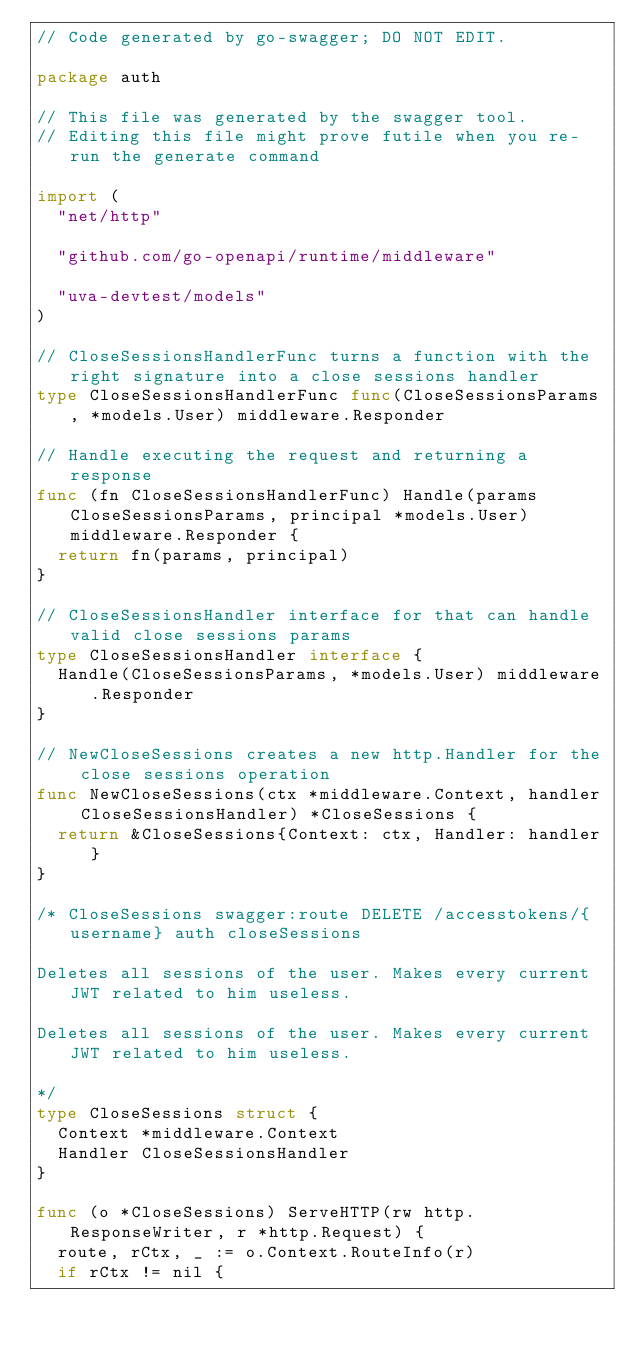Convert code to text. <code><loc_0><loc_0><loc_500><loc_500><_Go_>// Code generated by go-swagger; DO NOT EDIT.

package auth

// This file was generated by the swagger tool.
// Editing this file might prove futile when you re-run the generate command

import (
	"net/http"

	"github.com/go-openapi/runtime/middleware"

	"uva-devtest/models"
)

// CloseSessionsHandlerFunc turns a function with the right signature into a close sessions handler
type CloseSessionsHandlerFunc func(CloseSessionsParams, *models.User) middleware.Responder

// Handle executing the request and returning a response
func (fn CloseSessionsHandlerFunc) Handle(params CloseSessionsParams, principal *models.User) middleware.Responder {
	return fn(params, principal)
}

// CloseSessionsHandler interface for that can handle valid close sessions params
type CloseSessionsHandler interface {
	Handle(CloseSessionsParams, *models.User) middleware.Responder
}

// NewCloseSessions creates a new http.Handler for the close sessions operation
func NewCloseSessions(ctx *middleware.Context, handler CloseSessionsHandler) *CloseSessions {
	return &CloseSessions{Context: ctx, Handler: handler}
}

/* CloseSessions swagger:route DELETE /accesstokens/{username} auth closeSessions

Deletes all sessions of the user. Makes every current JWT related to him useless.

Deletes all sessions of the user. Makes every current JWT related to him useless.

*/
type CloseSessions struct {
	Context *middleware.Context
	Handler CloseSessionsHandler
}

func (o *CloseSessions) ServeHTTP(rw http.ResponseWriter, r *http.Request) {
	route, rCtx, _ := o.Context.RouteInfo(r)
	if rCtx != nil {</code> 